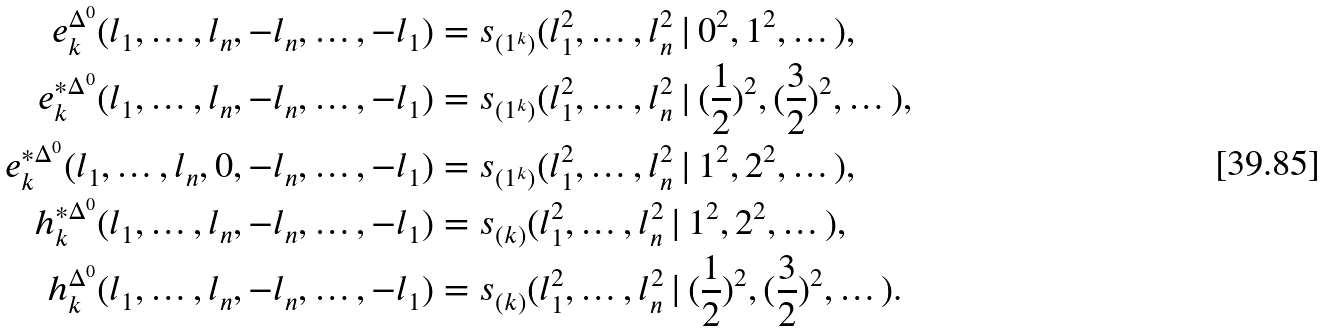<formula> <loc_0><loc_0><loc_500><loc_500>e ^ { \Delta ^ { 0 } } _ { k } ( l _ { 1 } , \dots , l _ { n } , - l _ { n } , \dots , - l _ { 1 } ) & = s _ { ( 1 ^ { k } ) } ( l _ { 1 } ^ { 2 } , \dots , l _ { n } ^ { 2 } \, | \, 0 ^ { 2 } , 1 ^ { 2 } , \dots ) , \\ e ^ { * \Delta ^ { 0 } } _ { k } ( l _ { 1 } , \dots , l _ { n } , - l _ { n } , \dots , - l _ { 1 } ) & = s _ { ( 1 ^ { k } ) } ( l _ { 1 } ^ { 2 } , \dots , l _ { n } ^ { 2 } \, | \, ( \frac { 1 } { 2 } ) ^ { 2 } , ( \frac { 3 } { 2 } ) ^ { 2 } , \dots ) , \\ e ^ { * \Delta ^ { 0 } } _ { k } ( l _ { 1 } , \dots , l _ { n } , 0 , - l _ { n } , \dots , - l _ { 1 } ) & = s _ { ( 1 ^ { k } ) } ( l _ { 1 } ^ { 2 } , \dots , l _ { n } ^ { 2 } \, | \, 1 ^ { 2 } , 2 ^ { 2 } , \dots ) , \\ h ^ { * \Delta ^ { 0 } } _ { k } ( l _ { 1 } , \dots , l _ { n } , - l _ { n } , \dots , - l _ { 1 } ) & = s _ { ( k ) } ( l _ { 1 } ^ { 2 } , \dots , l _ { n } ^ { 2 } \, | \, 1 ^ { 2 } , 2 ^ { 2 } , \dots ) , \\ h ^ { \Delta ^ { 0 } } _ { k } ( l _ { 1 } , \dots , l _ { n } , - l _ { n } , \dots , - l _ { 1 } ) & = s _ { ( k ) } ( l _ { 1 } ^ { 2 } , \dots , l _ { n } ^ { 2 } \, | \, ( \frac { 1 } { 2 } ) ^ { 2 } , ( \frac { 3 } { 2 } ) ^ { 2 } , \dots ) .</formula> 